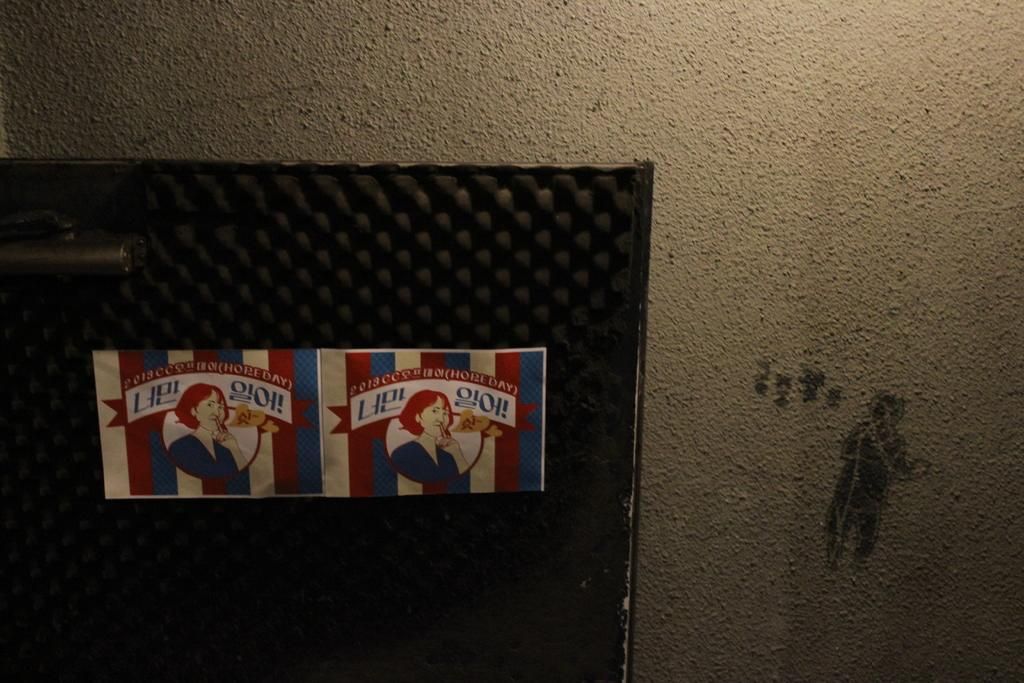How many posters can be seen in the image? There are two posters in the image. What is the color of the background behind the posters? The posters are on a black color background. What type of trouble is the deer causing in the image? There is no deer present in the image, so it is not possible to determine if there is any trouble or not. 